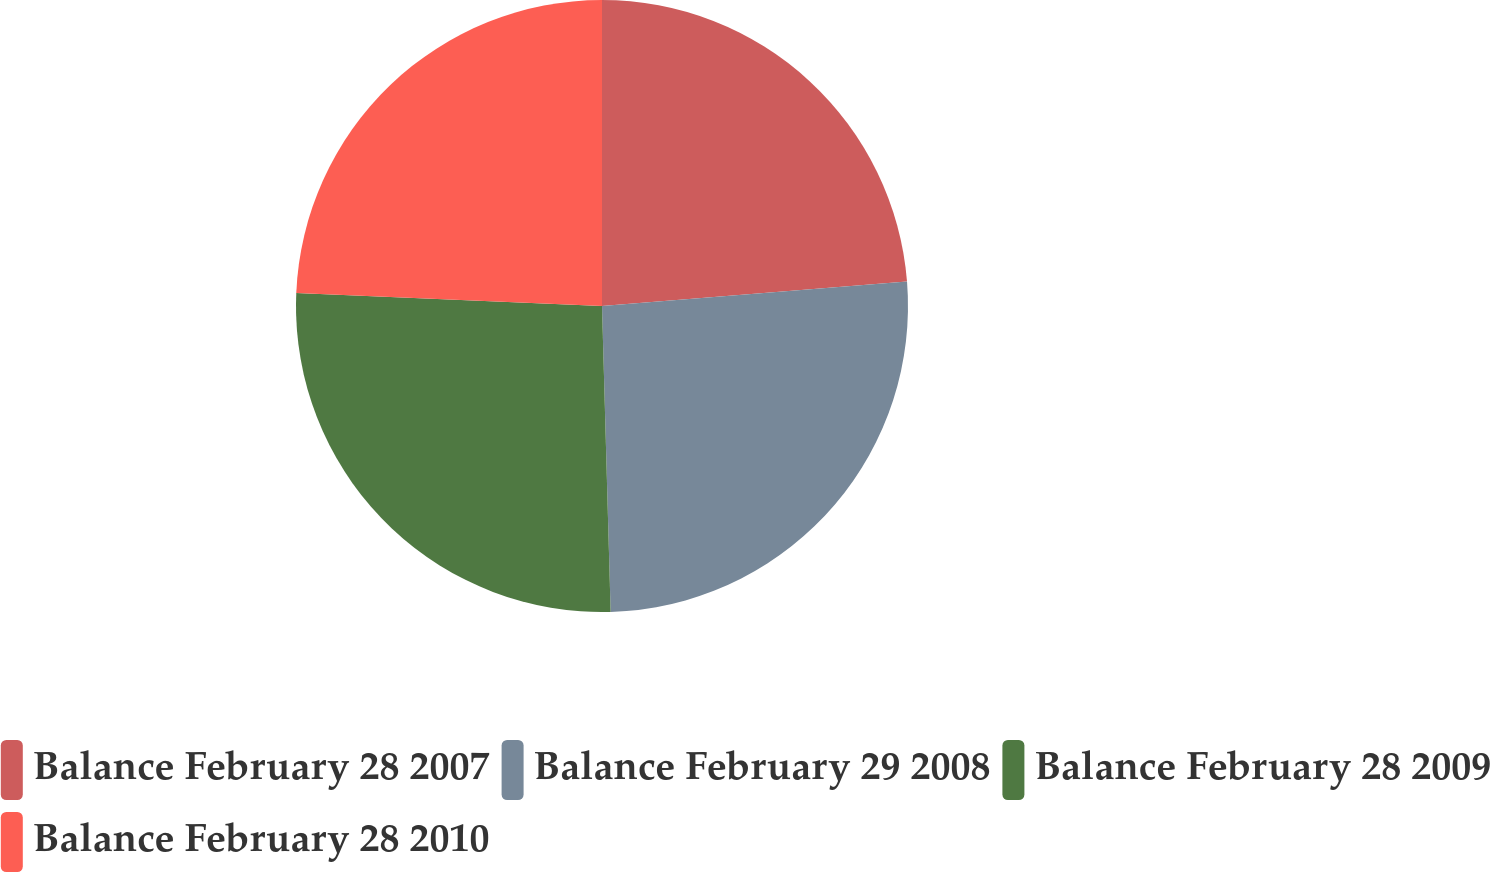<chart> <loc_0><loc_0><loc_500><loc_500><pie_chart><fcel>Balance February 28 2007<fcel>Balance February 29 2008<fcel>Balance February 28 2009<fcel>Balance February 28 2010<nl><fcel>23.73%<fcel>25.82%<fcel>26.13%<fcel>24.32%<nl></chart> 